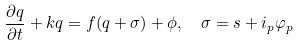<formula> <loc_0><loc_0><loc_500><loc_500>\frac { \partial q } { \partial t } + k q = f ( q + \sigma ) + \phi , \text { \ } \sigma = s + i _ { p } \varphi _ { p }</formula> 